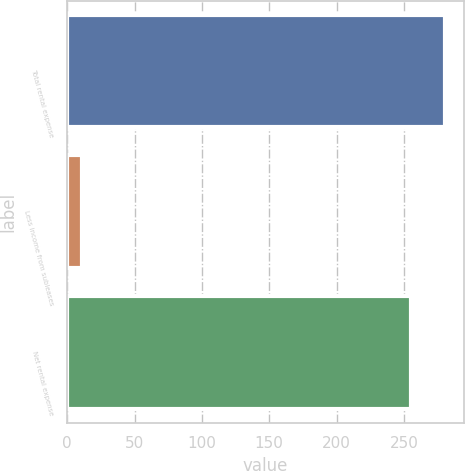Convert chart. <chart><loc_0><loc_0><loc_500><loc_500><bar_chart><fcel>Total rental expense<fcel>Less income from subleases<fcel>Net rental expense<nl><fcel>280.5<fcel>11<fcel>255<nl></chart> 